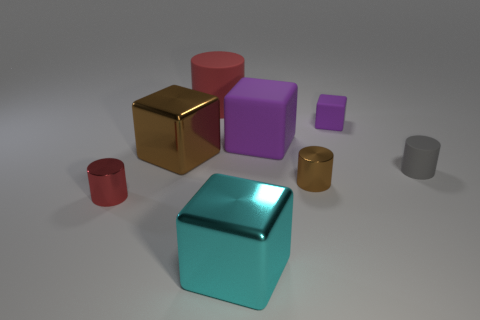Subtract 1 cylinders. How many cylinders are left? 3 Add 2 small green shiny cylinders. How many objects exist? 10 Subtract 1 brown cylinders. How many objects are left? 7 Subtract all yellow rubber cylinders. Subtract all gray things. How many objects are left? 7 Add 5 red metal objects. How many red metal objects are left? 6 Add 6 large cyan metal blocks. How many large cyan metal blocks exist? 7 